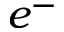<formula> <loc_0><loc_0><loc_500><loc_500>e ^ { - }</formula> 